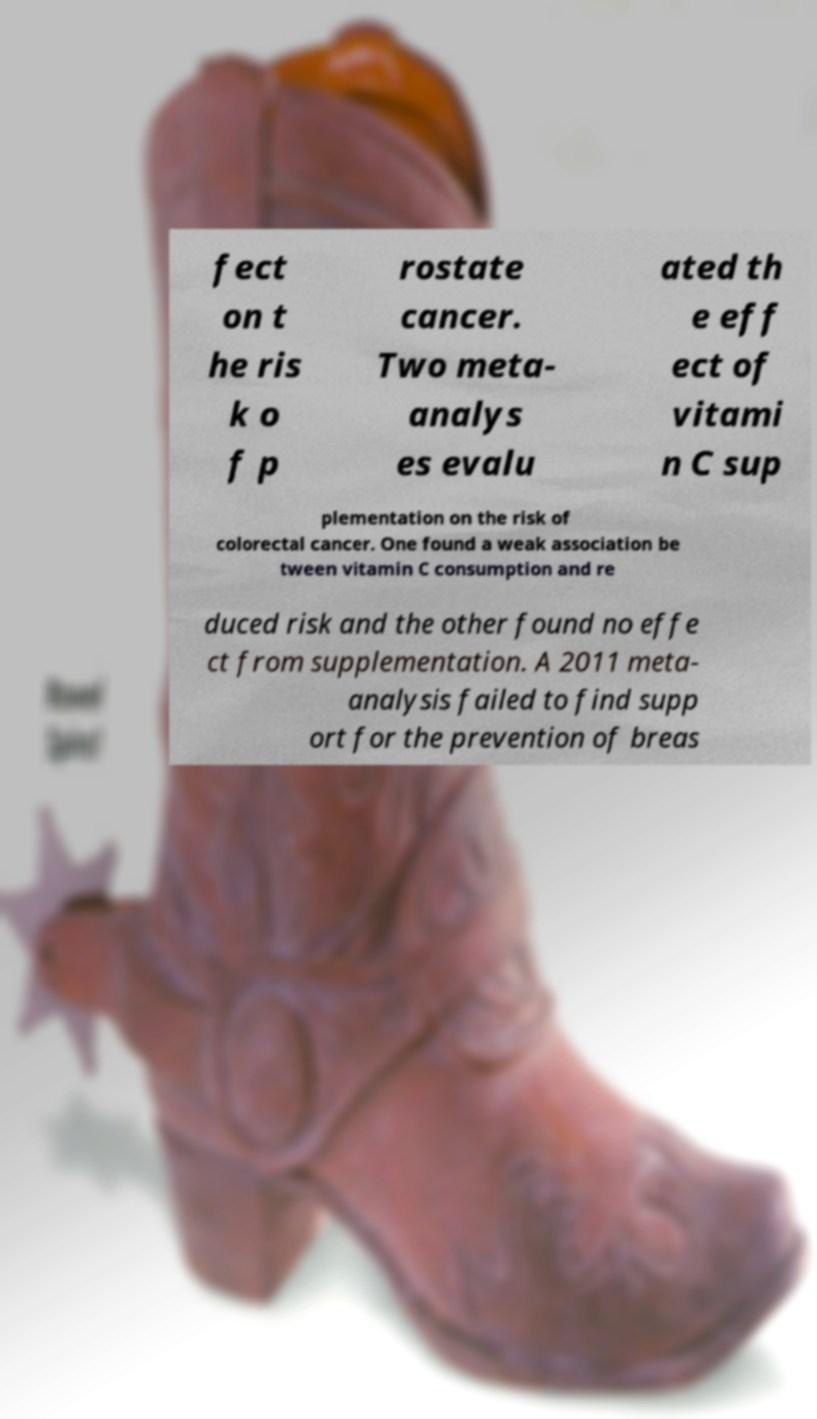Can you accurately transcribe the text from the provided image for me? fect on t he ris k o f p rostate cancer. Two meta- analys es evalu ated th e eff ect of vitami n C sup plementation on the risk of colorectal cancer. One found a weak association be tween vitamin C consumption and re duced risk and the other found no effe ct from supplementation. A 2011 meta- analysis failed to find supp ort for the prevention of breas 